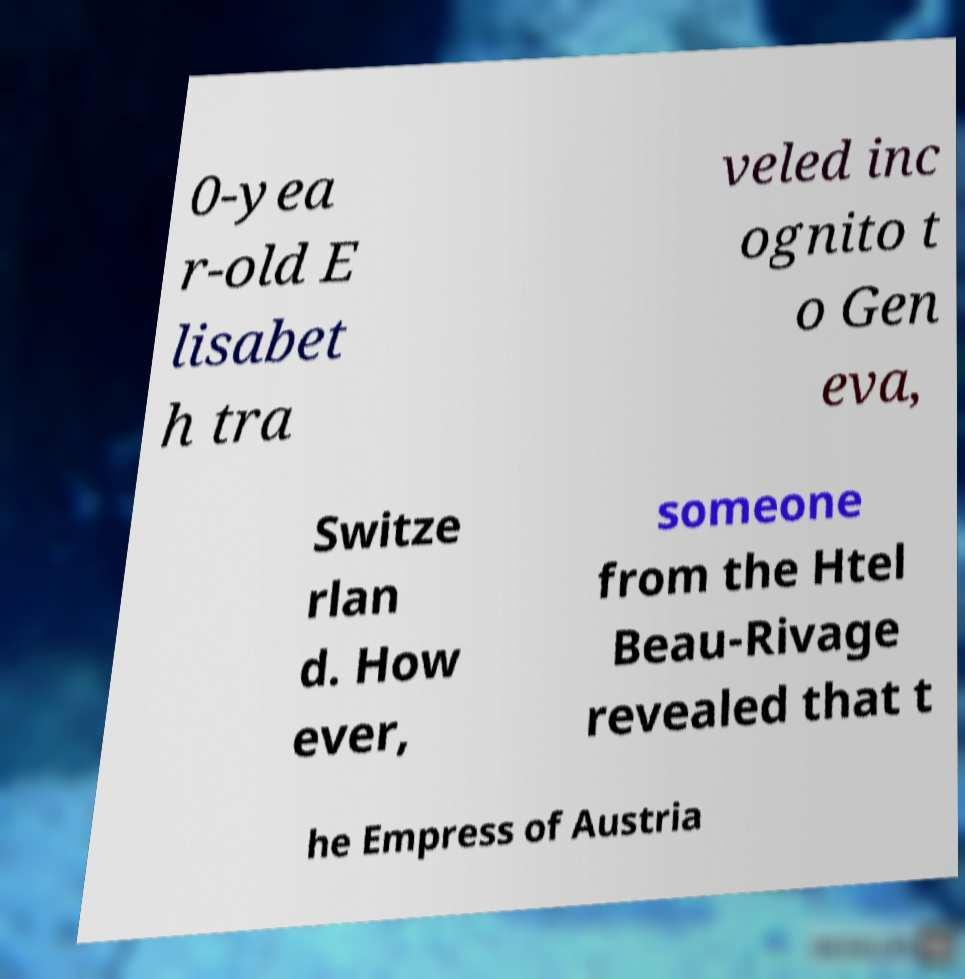Could you assist in decoding the text presented in this image and type it out clearly? 0-yea r-old E lisabet h tra veled inc ognito t o Gen eva, Switze rlan d. How ever, someone from the Htel Beau-Rivage revealed that t he Empress of Austria 